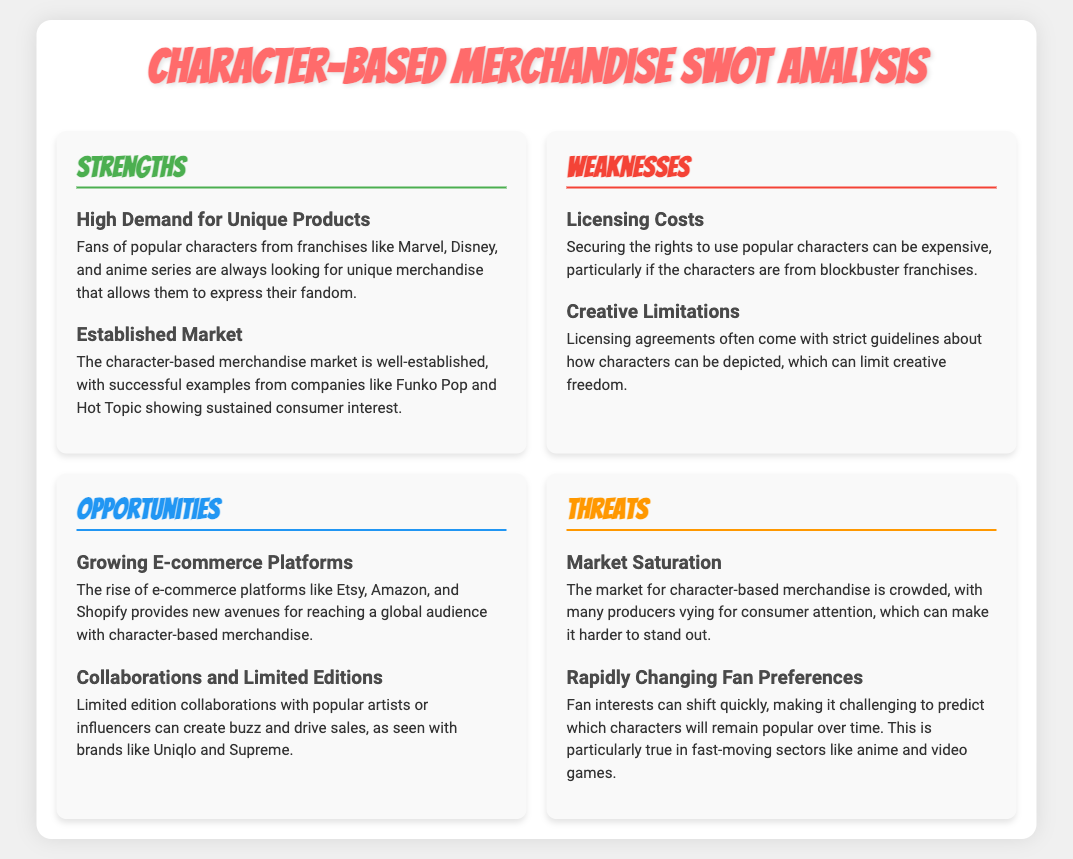What are fans looking for in merchandise? The document states that fans are looking for unique merchandise that allows them to express their fandom.
Answer: Unique products Which companies have successfully shown consumer interest in character-based merchandise? Funko Pop and Hot Topic are mentioned as successful examples in the document.
Answer: Funko Pop and Hot Topic What is a significant weakness related to character-based merchandise? The document highlights licensing costs as an expensive aspect of securing character rights.
Answer: Licensing costs What opportunity is mentioned concerning e-commerce? The document states that the rise of e-commerce platforms provides new avenues for sales.
Answer: Growing e-commerce platforms What are consumers competing for in character-based merchandise? The document indicates that many producers are vying for consumer attention, contributing to market saturation.
Answer: Consumer attention What type of collaborations can drive sales? The document mentions limited edition collaborations with popular artists or influencers.
Answer: Collaborations and limited editions What is a threat related to fan interests? The document outlines that fan interests can shift quickly, making predictions hard.
Answer: Rapidly changing fan preferences 